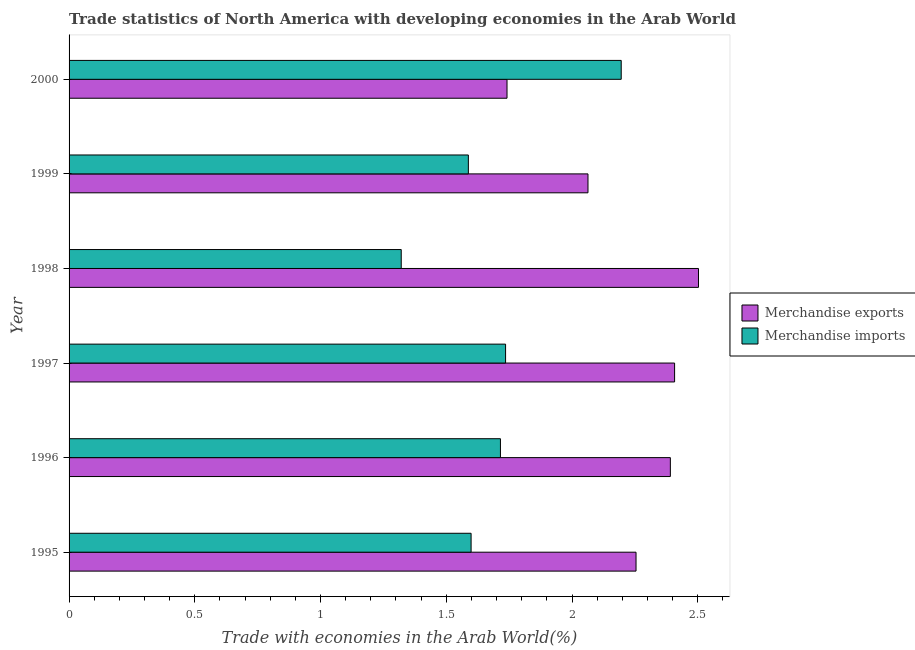How many different coloured bars are there?
Your answer should be compact. 2. How many groups of bars are there?
Keep it short and to the point. 6. Are the number of bars per tick equal to the number of legend labels?
Ensure brevity in your answer.  Yes. Are the number of bars on each tick of the Y-axis equal?
Your answer should be compact. Yes. How many bars are there on the 2nd tick from the bottom?
Offer a very short reply. 2. In how many cases, is the number of bars for a given year not equal to the number of legend labels?
Keep it short and to the point. 0. What is the merchandise imports in 1995?
Provide a short and direct response. 1.6. Across all years, what is the maximum merchandise exports?
Provide a short and direct response. 2.5. Across all years, what is the minimum merchandise imports?
Make the answer very short. 1.32. In which year was the merchandise exports maximum?
Give a very brief answer. 1998. What is the total merchandise imports in the graph?
Offer a very short reply. 10.15. What is the difference between the merchandise exports in 1995 and that in 2000?
Offer a very short reply. 0.51. What is the difference between the merchandise exports in 1999 and the merchandise imports in 1997?
Ensure brevity in your answer.  0.33. What is the average merchandise imports per year?
Ensure brevity in your answer.  1.69. In the year 1998, what is the difference between the merchandise exports and merchandise imports?
Offer a terse response. 1.18. What is the ratio of the merchandise exports in 1998 to that in 1999?
Provide a short and direct response. 1.21. Is the merchandise imports in 1995 less than that in 1999?
Give a very brief answer. No. Is the difference between the merchandise imports in 1996 and 2000 greater than the difference between the merchandise exports in 1996 and 2000?
Provide a succinct answer. No. What is the difference between the highest and the second highest merchandise exports?
Your answer should be very brief. 0.1. What is the difference between the highest and the lowest merchandise imports?
Provide a short and direct response. 0.87. In how many years, is the merchandise exports greater than the average merchandise exports taken over all years?
Make the answer very short. 4. How many bars are there?
Ensure brevity in your answer.  12. How many legend labels are there?
Provide a succinct answer. 2. What is the title of the graph?
Ensure brevity in your answer.  Trade statistics of North America with developing economies in the Arab World. What is the label or title of the X-axis?
Offer a terse response. Trade with economies in the Arab World(%). What is the label or title of the Y-axis?
Your answer should be compact. Year. What is the Trade with economies in the Arab World(%) of Merchandise exports in 1995?
Keep it short and to the point. 2.25. What is the Trade with economies in the Arab World(%) of Merchandise imports in 1995?
Keep it short and to the point. 1.6. What is the Trade with economies in the Arab World(%) of Merchandise exports in 1996?
Offer a very short reply. 2.39. What is the Trade with economies in the Arab World(%) in Merchandise imports in 1996?
Provide a succinct answer. 1.72. What is the Trade with economies in the Arab World(%) of Merchandise exports in 1997?
Give a very brief answer. 2.41. What is the Trade with economies in the Arab World(%) in Merchandise imports in 1997?
Keep it short and to the point. 1.74. What is the Trade with economies in the Arab World(%) of Merchandise exports in 1998?
Your answer should be very brief. 2.5. What is the Trade with economies in the Arab World(%) in Merchandise imports in 1998?
Ensure brevity in your answer.  1.32. What is the Trade with economies in the Arab World(%) in Merchandise exports in 1999?
Keep it short and to the point. 2.06. What is the Trade with economies in the Arab World(%) in Merchandise imports in 1999?
Provide a succinct answer. 1.59. What is the Trade with economies in the Arab World(%) in Merchandise exports in 2000?
Make the answer very short. 1.74. What is the Trade with economies in the Arab World(%) in Merchandise imports in 2000?
Your answer should be very brief. 2.2. Across all years, what is the maximum Trade with economies in the Arab World(%) in Merchandise exports?
Provide a succinct answer. 2.5. Across all years, what is the maximum Trade with economies in the Arab World(%) of Merchandise imports?
Offer a very short reply. 2.2. Across all years, what is the minimum Trade with economies in the Arab World(%) in Merchandise exports?
Provide a succinct answer. 1.74. Across all years, what is the minimum Trade with economies in the Arab World(%) of Merchandise imports?
Your answer should be very brief. 1.32. What is the total Trade with economies in the Arab World(%) in Merchandise exports in the graph?
Give a very brief answer. 13.36. What is the total Trade with economies in the Arab World(%) in Merchandise imports in the graph?
Give a very brief answer. 10.15. What is the difference between the Trade with economies in the Arab World(%) of Merchandise exports in 1995 and that in 1996?
Your answer should be compact. -0.14. What is the difference between the Trade with economies in the Arab World(%) of Merchandise imports in 1995 and that in 1996?
Ensure brevity in your answer.  -0.12. What is the difference between the Trade with economies in the Arab World(%) of Merchandise exports in 1995 and that in 1997?
Ensure brevity in your answer.  -0.15. What is the difference between the Trade with economies in the Arab World(%) of Merchandise imports in 1995 and that in 1997?
Your answer should be compact. -0.14. What is the difference between the Trade with economies in the Arab World(%) in Merchandise exports in 1995 and that in 1998?
Ensure brevity in your answer.  -0.25. What is the difference between the Trade with economies in the Arab World(%) of Merchandise imports in 1995 and that in 1998?
Offer a very short reply. 0.28. What is the difference between the Trade with economies in the Arab World(%) of Merchandise exports in 1995 and that in 1999?
Ensure brevity in your answer.  0.19. What is the difference between the Trade with economies in the Arab World(%) of Merchandise imports in 1995 and that in 1999?
Ensure brevity in your answer.  0.01. What is the difference between the Trade with economies in the Arab World(%) of Merchandise exports in 1995 and that in 2000?
Your response must be concise. 0.51. What is the difference between the Trade with economies in the Arab World(%) in Merchandise imports in 1995 and that in 2000?
Your response must be concise. -0.6. What is the difference between the Trade with economies in the Arab World(%) of Merchandise exports in 1996 and that in 1997?
Make the answer very short. -0.02. What is the difference between the Trade with economies in the Arab World(%) in Merchandise imports in 1996 and that in 1997?
Provide a short and direct response. -0.02. What is the difference between the Trade with economies in the Arab World(%) of Merchandise exports in 1996 and that in 1998?
Your answer should be compact. -0.11. What is the difference between the Trade with economies in the Arab World(%) in Merchandise imports in 1996 and that in 1998?
Your answer should be compact. 0.39. What is the difference between the Trade with economies in the Arab World(%) of Merchandise exports in 1996 and that in 1999?
Your response must be concise. 0.33. What is the difference between the Trade with economies in the Arab World(%) of Merchandise imports in 1996 and that in 1999?
Ensure brevity in your answer.  0.13. What is the difference between the Trade with economies in the Arab World(%) of Merchandise exports in 1996 and that in 2000?
Offer a terse response. 0.65. What is the difference between the Trade with economies in the Arab World(%) of Merchandise imports in 1996 and that in 2000?
Provide a succinct answer. -0.48. What is the difference between the Trade with economies in the Arab World(%) in Merchandise exports in 1997 and that in 1998?
Provide a short and direct response. -0.1. What is the difference between the Trade with economies in the Arab World(%) in Merchandise imports in 1997 and that in 1998?
Your answer should be compact. 0.41. What is the difference between the Trade with economies in the Arab World(%) of Merchandise exports in 1997 and that in 1999?
Give a very brief answer. 0.34. What is the difference between the Trade with economies in the Arab World(%) in Merchandise imports in 1997 and that in 1999?
Offer a terse response. 0.15. What is the difference between the Trade with economies in the Arab World(%) of Merchandise exports in 1997 and that in 2000?
Offer a very short reply. 0.67. What is the difference between the Trade with economies in the Arab World(%) of Merchandise imports in 1997 and that in 2000?
Your answer should be very brief. -0.46. What is the difference between the Trade with economies in the Arab World(%) of Merchandise exports in 1998 and that in 1999?
Give a very brief answer. 0.44. What is the difference between the Trade with economies in the Arab World(%) in Merchandise imports in 1998 and that in 1999?
Offer a terse response. -0.27. What is the difference between the Trade with economies in the Arab World(%) in Merchandise exports in 1998 and that in 2000?
Give a very brief answer. 0.76. What is the difference between the Trade with economies in the Arab World(%) of Merchandise imports in 1998 and that in 2000?
Give a very brief answer. -0.87. What is the difference between the Trade with economies in the Arab World(%) of Merchandise exports in 1999 and that in 2000?
Give a very brief answer. 0.32. What is the difference between the Trade with economies in the Arab World(%) of Merchandise imports in 1999 and that in 2000?
Your answer should be compact. -0.61. What is the difference between the Trade with economies in the Arab World(%) in Merchandise exports in 1995 and the Trade with economies in the Arab World(%) in Merchandise imports in 1996?
Give a very brief answer. 0.54. What is the difference between the Trade with economies in the Arab World(%) in Merchandise exports in 1995 and the Trade with economies in the Arab World(%) in Merchandise imports in 1997?
Make the answer very short. 0.52. What is the difference between the Trade with economies in the Arab World(%) in Merchandise exports in 1995 and the Trade with economies in the Arab World(%) in Merchandise imports in 1998?
Give a very brief answer. 0.93. What is the difference between the Trade with economies in the Arab World(%) in Merchandise exports in 1995 and the Trade with economies in the Arab World(%) in Merchandise imports in 1999?
Your answer should be compact. 0.67. What is the difference between the Trade with economies in the Arab World(%) of Merchandise exports in 1995 and the Trade with economies in the Arab World(%) of Merchandise imports in 2000?
Your answer should be compact. 0.06. What is the difference between the Trade with economies in the Arab World(%) of Merchandise exports in 1996 and the Trade with economies in the Arab World(%) of Merchandise imports in 1997?
Provide a short and direct response. 0.66. What is the difference between the Trade with economies in the Arab World(%) of Merchandise exports in 1996 and the Trade with economies in the Arab World(%) of Merchandise imports in 1998?
Provide a succinct answer. 1.07. What is the difference between the Trade with economies in the Arab World(%) of Merchandise exports in 1996 and the Trade with economies in the Arab World(%) of Merchandise imports in 1999?
Make the answer very short. 0.8. What is the difference between the Trade with economies in the Arab World(%) of Merchandise exports in 1996 and the Trade with economies in the Arab World(%) of Merchandise imports in 2000?
Your answer should be very brief. 0.2. What is the difference between the Trade with economies in the Arab World(%) in Merchandise exports in 1997 and the Trade with economies in the Arab World(%) in Merchandise imports in 1998?
Provide a succinct answer. 1.09. What is the difference between the Trade with economies in the Arab World(%) in Merchandise exports in 1997 and the Trade with economies in the Arab World(%) in Merchandise imports in 1999?
Your response must be concise. 0.82. What is the difference between the Trade with economies in the Arab World(%) in Merchandise exports in 1997 and the Trade with economies in the Arab World(%) in Merchandise imports in 2000?
Your response must be concise. 0.21. What is the difference between the Trade with economies in the Arab World(%) of Merchandise exports in 1998 and the Trade with economies in the Arab World(%) of Merchandise imports in 1999?
Your answer should be compact. 0.92. What is the difference between the Trade with economies in the Arab World(%) in Merchandise exports in 1998 and the Trade with economies in the Arab World(%) in Merchandise imports in 2000?
Offer a terse response. 0.31. What is the difference between the Trade with economies in the Arab World(%) in Merchandise exports in 1999 and the Trade with economies in the Arab World(%) in Merchandise imports in 2000?
Offer a very short reply. -0.13. What is the average Trade with economies in the Arab World(%) of Merchandise exports per year?
Your response must be concise. 2.23. What is the average Trade with economies in the Arab World(%) of Merchandise imports per year?
Give a very brief answer. 1.69. In the year 1995, what is the difference between the Trade with economies in the Arab World(%) of Merchandise exports and Trade with economies in the Arab World(%) of Merchandise imports?
Give a very brief answer. 0.66. In the year 1996, what is the difference between the Trade with economies in the Arab World(%) of Merchandise exports and Trade with economies in the Arab World(%) of Merchandise imports?
Your answer should be very brief. 0.68. In the year 1997, what is the difference between the Trade with economies in the Arab World(%) of Merchandise exports and Trade with economies in the Arab World(%) of Merchandise imports?
Your answer should be very brief. 0.67. In the year 1998, what is the difference between the Trade with economies in the Arab World(%) of Merchandise exports and Trade with economies in the Arab World(%) of Merchandise imports?
Ensure brevity in your answer.  1.18. In the year 1999, what is the difference between the Trade with economies in the Arab World(%) in Merchandise exports and Trade with economies in the Arab World(%) in Merchandise imports?
Give a very brief answer. 0.48. In the year 2000, what is the difference between the Trade with economies in the Arab World(%) of Merchandise exports and Trade with economies in the Arab World(%) of Merchandise imports?
Ensure brevity in your answer.  -0.45. What is the ratio of the Trade with economies in the Arab World(%) of Merchandise exports in 1995 to that in 1996?
Make the answer very short. 0.94. What is the ratio of the Trade with economies in the Arab World(%) of Merchandise imports in 1995 to that in 1996?
Provide a short and direct response. 0.93. What is the ratio of the Trade with economies in the Arab World(%) in Merchandise exports in 1995 to that in 1997?
Your answer should be compact. 0.94. What is the ratio of the Trade with economies in the Arab World(%) of Merchandise imports in 1995 to that in 1997?
Offer a very short reply. 0.92. What is the ratio of the Trade with economies in the Arab World(%) in Merchandise exports in 1995 to that in 1998?
Give a very brief answer. 0.9. What is the ratio of the Trade with economies in the Arab World(%) of Merchandise imports in 1995 to that in 1998?
Offer a terse response. 1.21. What is the ratio of the Trade with economies in the Arab World(%) in Merchandise exports in 1995 to that in 1999?
Provide a succinct answer. 1.09. What is the ratio of the Trade with economies in the Arab World(%) of Merchandise imports in 1995 to that in 1999?
Make the answer very short. 1.01. What is the ratio of the Trade with economies in the Arab World(%) of Merchandise exports in 1995 to that in 2000?
Your answer should be very brief. 1.29. What is the ratio of the Trade with economies in the Arab World(%) of Merchandise imports in 1995 to that in 2000?
Give a very brief answer. 0.73. What is the ratio of the Trade with economies in the Arab World(%) of Merchandise exports in 1996 to that in 1997?
Your response must be concise. 0.99. What is the ratio of the Trade with economies in the Arab World(%) of Merchandise imports in 1996 to that in 1997?
Your answer should be compact. 0.99. What is the ratio of the Trade with economies in the Arab World(%) of Merchandise exports in 1996 to that in 1998?
Give a very brief answer. 0.96. What is the ratio of the Trade with economies in the Arab World(%) in Merchandise imports in 1996 to that in 1998?
Provide a succinct answer. 1.3. What is the ratio of the Trade with economies in the Arab World(%) in Merchandise exports in 1996 to that in 1999?
Give a very brief answer. 1.16. What is the ratio of the Trade with economies in the Arab World(%) in Merchandise imports in 1996 to that in 1999?
Your answer should be compact. 1.08. What is the ratio of the Trade with economies in the Arab World(%) of Merchandise exports in 1996 to that in 2000?
Your answer should be very brief. 1.37. What is the ratio of the Trade with economies in the Arab World(%) in Merchandise imports in 1996 to that in 2000?
Ensure brevity in your answer.  0.78. What is the ratio of the Trade with economies in the Arab World(%) of Merchandise imports in 1997 to that in 1998?
Make the answer very short. 1.31. What is the ratio of the Trade with economies in the Arab World(%) in Merchandise exports in 1997 to that in 1999?
Offer a terse response. 1.17. What is the ratio of the Trade with economies in the Arab World(%) in Merchandise imports in 1997 to that in 1999?
Provide a succinct answer. 1.09. What is the ratio of the Trade with economies in the Arab World(%) of Merchandise exports in 1997 to that in 2000?
Offer a very short reply. 1.38. What is the ratio of the Trade with economies in the Arab World(%) of Merchandise imports in 1997 to that in 2000?
Ensure brevity in your answer.  0.79. What is the ratio of the Trade with economies in the Arab World(%) in Merchandise exports in 1998 to that in 1999?
Make the answer very short. 1.21. What is the ratio of the Trade with economies in the Arab World(%) in Merchandise imports in 1998 to that in 1999?
Provide a short and direct response. 0.83. What is the ratio of the Trade with economies in the Arab World(%) of Merchandise exports in 1998 to that in 2000?
Provide a short and direct response. 1.44. What is the ratio of the Trade with economies in the Arab World(%) in Merchandise imports in 1998 to that in 2000?
Ensure brevity in your answer.  0.6. What is the ratio of the Trade with economies in the Arab World(%) of Merchandise exports in 1999 to that in 2000?
Ensure brevity in your answer.  1.18. What is the ratio of the Trade with economies in the Arab World(%) in Merchandise imports in 1999 to that in 2000?
Ensure brevity in your answer.  0.72. What is the difference between the highest and the second highest Trade with economies in the Arab World(%) of Merchandise exports?
Offer a very short reply. 0.1. What is the difference between the highest and the second highest Trade with economies in the Arab World(%) of Merchandise imports?
Your response must be concise. 0.46. What is the difference between the highest and the lowest Trade with economies in the Arab World(%) of Merchandise exports?
Offer a very short reply. 0.76. What is the difference between the highest and the lowest Trade with economies in the Arab World(%) in Merchandise imports?
Make the answer very short. 0.87. 